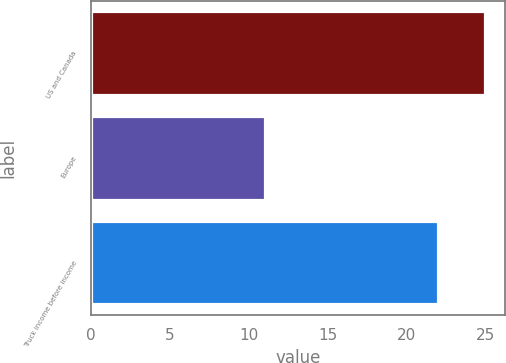Convert chart. <chart><loc_0><loc_0><loc_500><loc_500><bar_chart><fcel>US and Canada<fcel>Europe<fcel>Truck income before income<nl><fcel>25<fcel>11<fcel>22<nl></chart> 